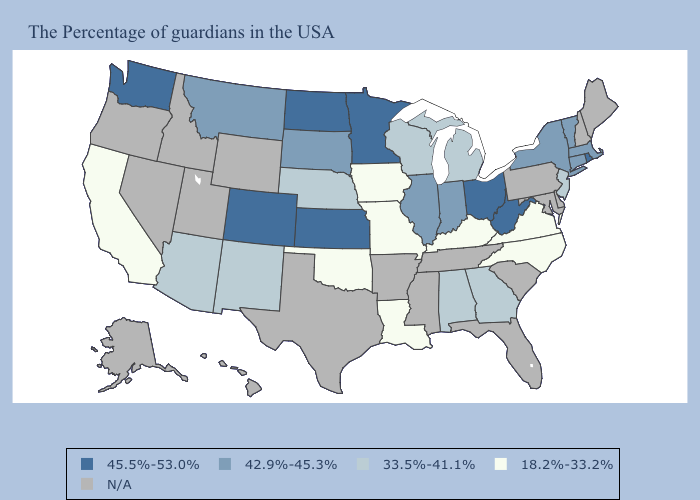Which states have the lowest value in the USA?
Quick response, please. Virginia, North Carolina, Kentucky, Louisiana, Missouri, Iowa, Oklahoma, California. What is the highest value in the South ?
Write a very short answer. 45.5%-53.0%. What is the highest value in the MidWest ?
Write a very short answer. 45.5%-53.0%. Which states have the lowest value in the Northeast?
Short answer required. New Jersey. What is the value of New York?
Quick response, please. 42.9%-45.3%. Which states have the highest value in the USA?
Write a very short answer. Rhode Island, West Virginia, Ohio, Minnesota, Kansas, North Dakota, Colorado, Washington. What is the value of Vermont?
Give a very brief answer. 42.9%-45.3%. What is the value of North Carolina?
Answer briefly. 18.2%-33.2%. Which states have the lowest value in the West?
Keep it brief. California. Which states hav the highest value in the MidWest?
Keep it brief. Ohio, Minnesota, Kansas, North Dakota. What is the value of South Dakota?
Write a very short answer. 42.9%-45.3%. Among the states that border Florida , which have the lowest value?
Short answer required. Georgia, Alabama. Among the states that border Connecticut , which have the highest value?
Answer briefly. Rhode Island. What is the value of Kentucky?
Answer briefly. 18.2%-33.2%. 